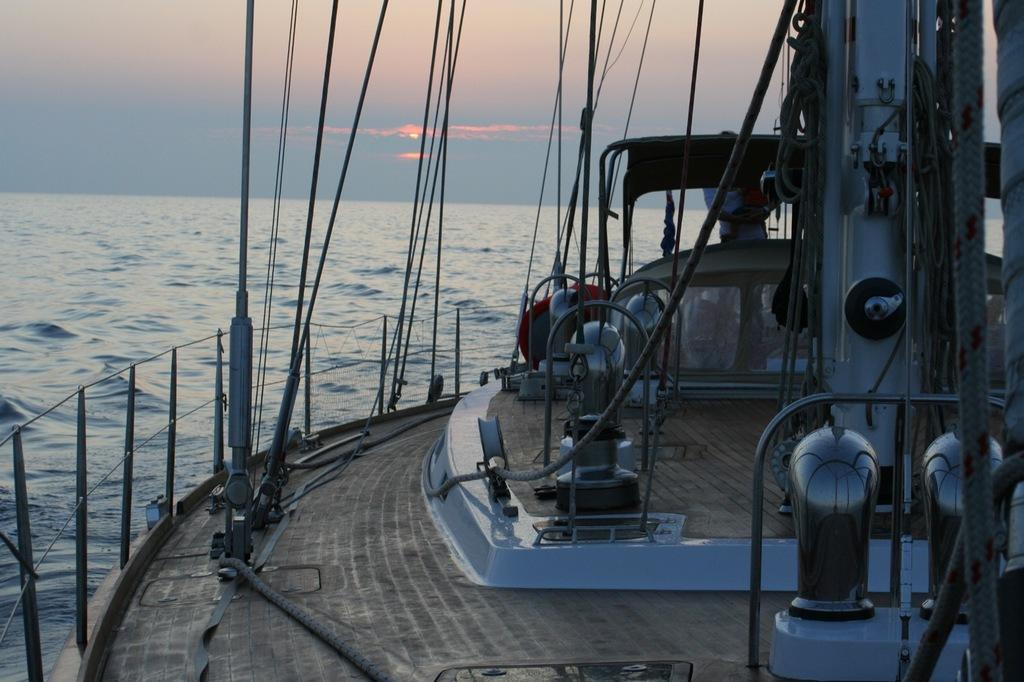What structures can be seen in the image? There are poles and a fence in the image. What are the poles used for? There are devices on the poles, which suggests they might be used for supporting or holding something. What else can be seen in the image besides the poles and fence? There are ropes in the image. What is the large body of water visible in the image? The large water body visible in the image is likely a lake or a river. How would you describe the weather in the image? The sky is cloudy in the image, which suggests that it might be overcast or there could be a chance of rain. What type of plantation can be seen growing near the water body in the image? There is no plantation visible in the image; it only shows poles, a fence, ropes, and devices on the poles. What material is the nest made of that is located on the pole in the image? There is no nest present on the pole in the image. 